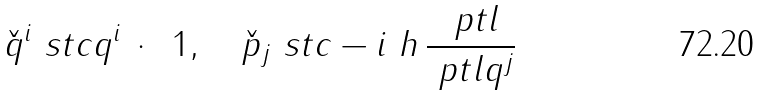<formula> <loc_0><loc_0><loc_500><loc_500>\check { q } ^ { i } \ s t c q ^ { i } \, \cdot \, \ 1 , \quad \check { p } _ { j } \ s t c - i \ h \, \frac { \ p t l } { \ p t l q ^ { j } }</formula> 